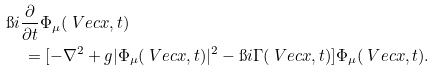Convert formula to latex. <formula><loc_0><loc_0><loc_500><loc_500>& \i i \frac { \partial } { \partial t } \Phi _ { \mu } ( \ V e c { x } , t ) \\ & \quad = [ - \nabla ^ { 2 } + g | \Phi _ { \mu } ( \ V e c { x } , t ) | ^ { 2 } - \i i \Gamma ( \ V e c { x } , t ) ] \Phi _ { \mu } ( \ V e c { x } , t ) .</formula> 